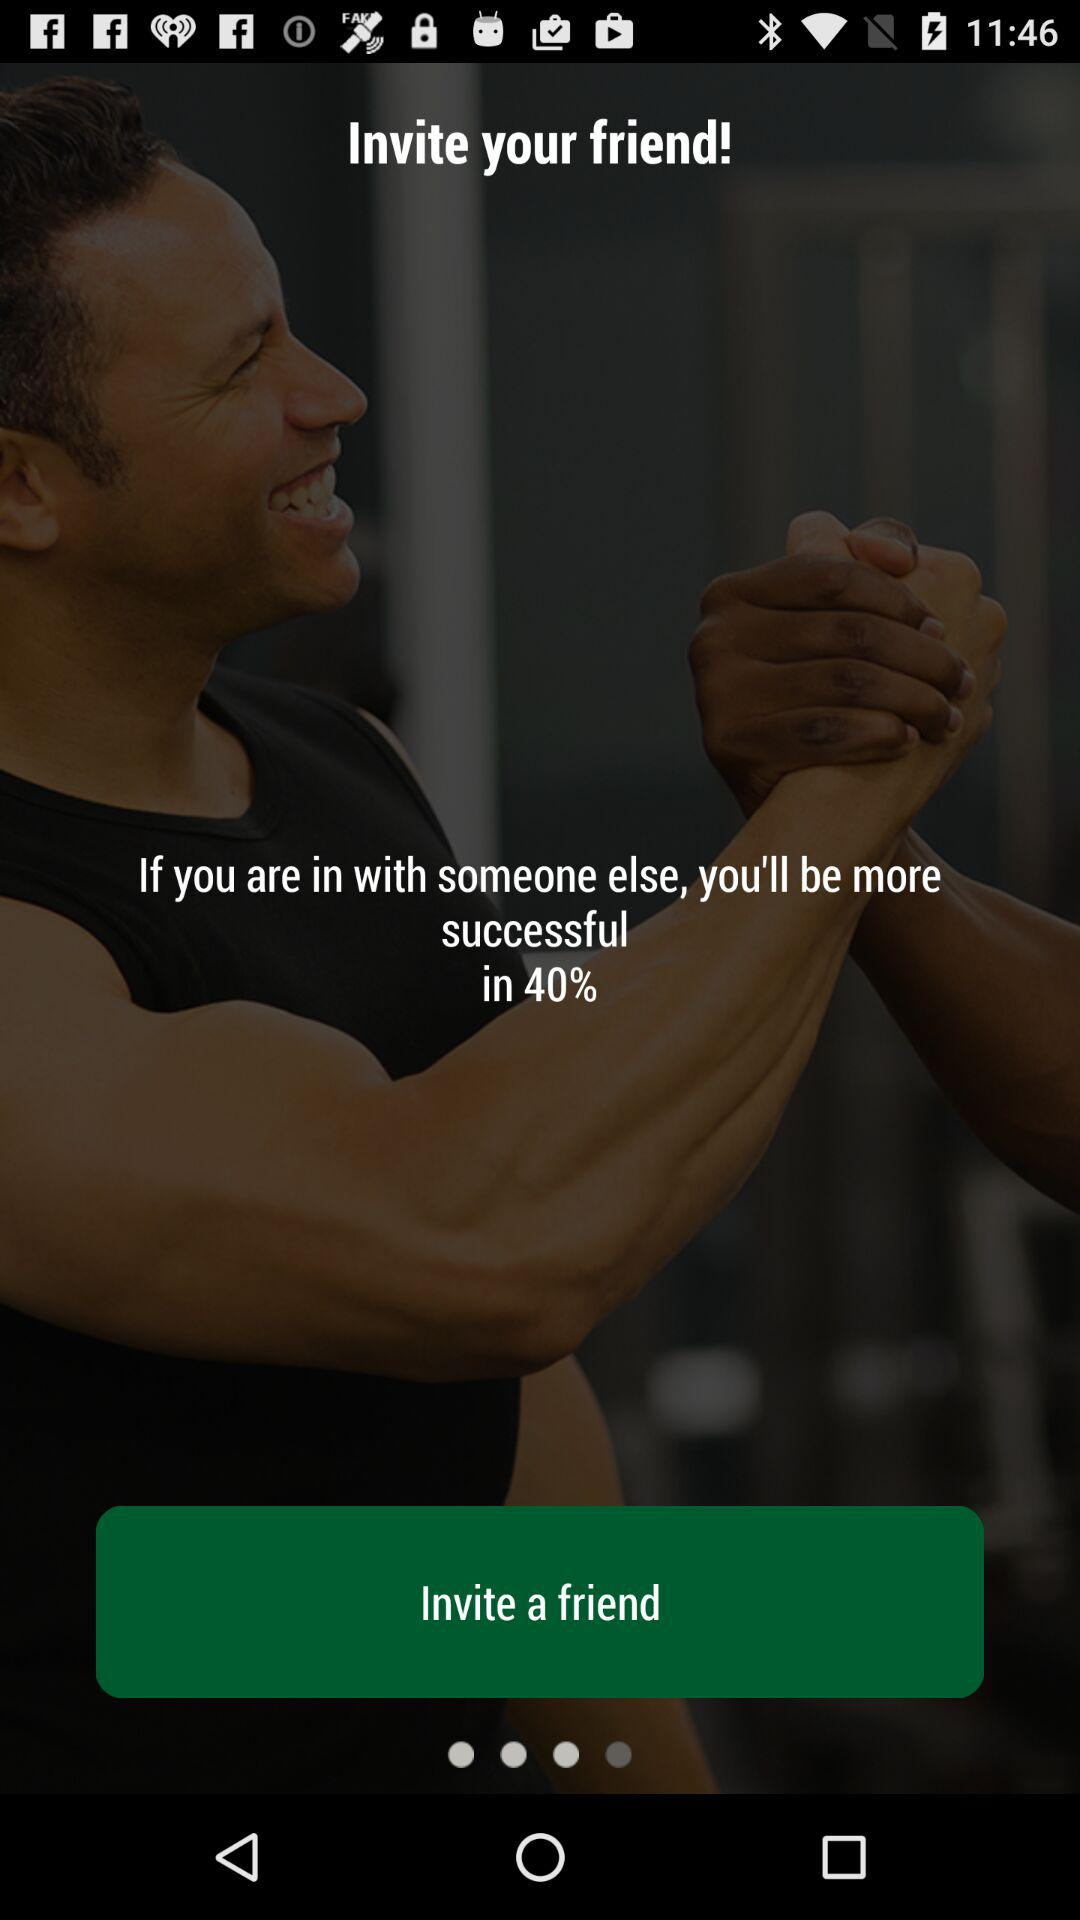What is the percentage? The percentage is 40. 